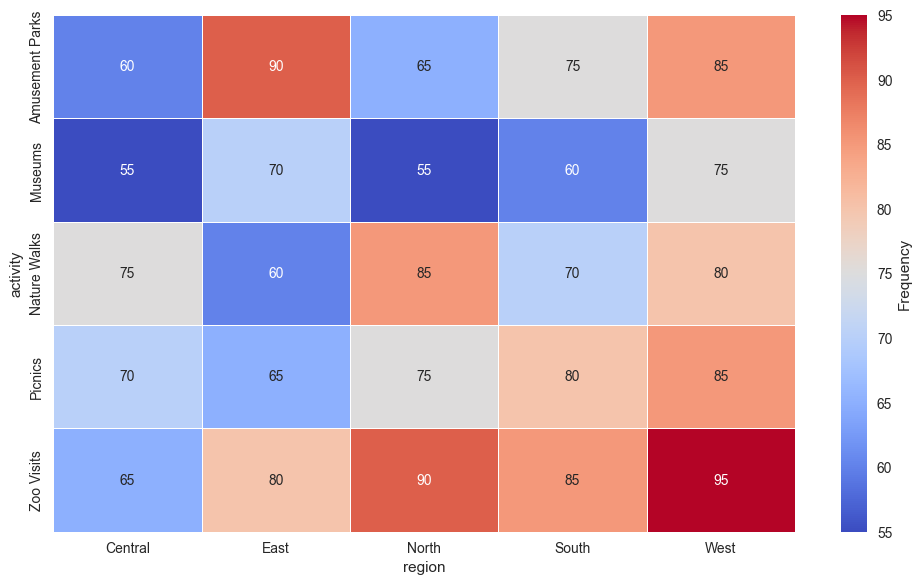What's the most preferred leisure activity in the North region? Look for the highest frequency value in the North column. The highest value is 90 for Zoo Visits.
Answer: Zoo Visits Which region has the least frequency for Amusement Parks? Check the frequency values for Amusement Parks across all regions. The lowest frequency is 60 in the Central region.
Answer: Central Is the frequency of Nature Walks greater in the West or the South region? Compare the frequency values for Nature Walks in the West and South columns. The West has 80, and the South has 70.
Answer: West What’s the average frequency of Zoo Visits across all regions? Sum the frequencies of Zoo Visits from all regions (90+85+80+95+65) and divide by the number of regions, which is 5. So, (90 + 85 + 80 + 95 + 65) / 5 = 83
Answer: 83 By how much do Picnics in the North region outnumber the Picnics in the East region? Subtract the frequency of Picnics in the East (65) from the frequency of Picnics in the North (75). So, 75 - 65 = 10
Answer: 10 Which region has the highest total frequency for all activities combined? Sum the frequency values for all activities in each region and compare the sums. North: 85+75+90+55+65 = 370; South: 70+80+85+60+75 = 370; East: 60+65+80+70+90 = 365; West: 80+85+95+75+85 = 420; Central: 75+70+65+55+60 = 325. The highest total is 420 for the West region.
Answer: West Which activity in the Central region has the lowest frequency? Look for the smallest frequency value in the Central column. The lowest value is 55 for Museums.
Answer: Museums Compare the frequencies of Museums visits between the North and East regions. Look at the frequency values for Museums in both regions. North has 55 and East has 70.
Answer: East Is the frequency of Amusement Parks in the East higher than in the North? Compare the frequency values for Amusement Parks between the East (90) and North (65). Yes, 90 is higher than 65.
Answer: Yes What's the combined frequency of Museum visits in the North and Central regions? Add the frequency values of Museums in both regions. North is 55 and Central is 55, so 55 + 55 = 110.
Answer: 110 